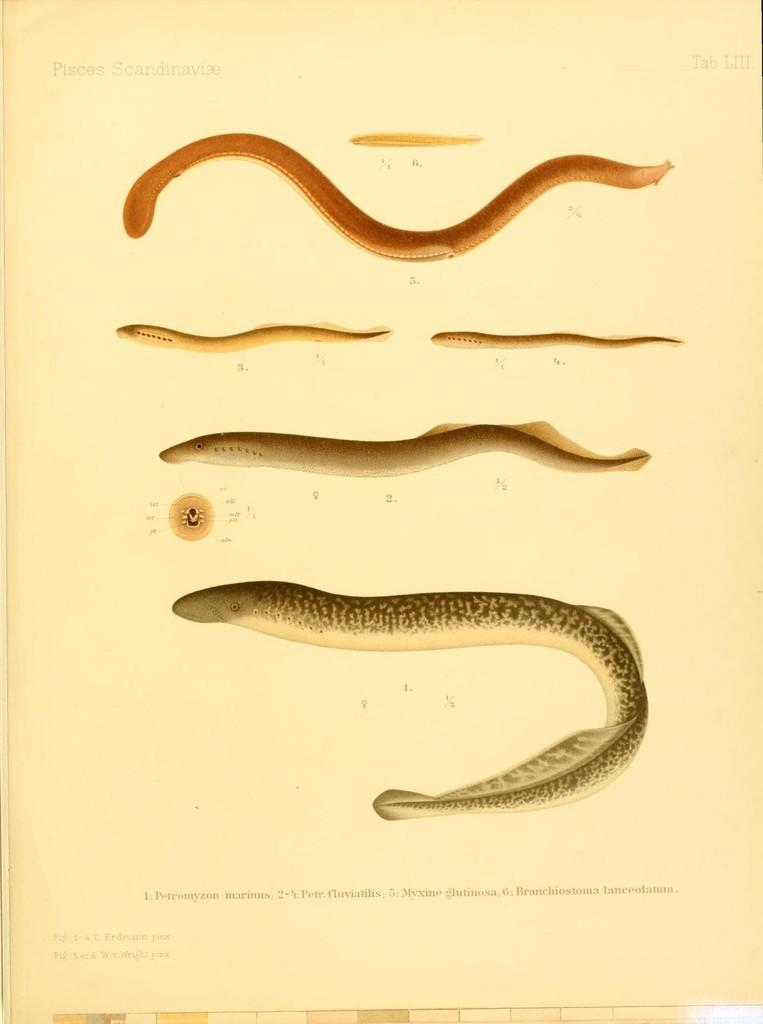What is present on the paper in the image? The paper contains images, numbers, and words. Can you describe the content of the paper in more detail? The paper contains images, numbers, and words, which may include a combination of visuals, numerical data, and written text. How many snails can be seen crawling on the paper in the image? There are no snails present on the paper in the image. What type of farmer is depicted on the paper in the image? There is no farmer depicted on the paper in the image. 